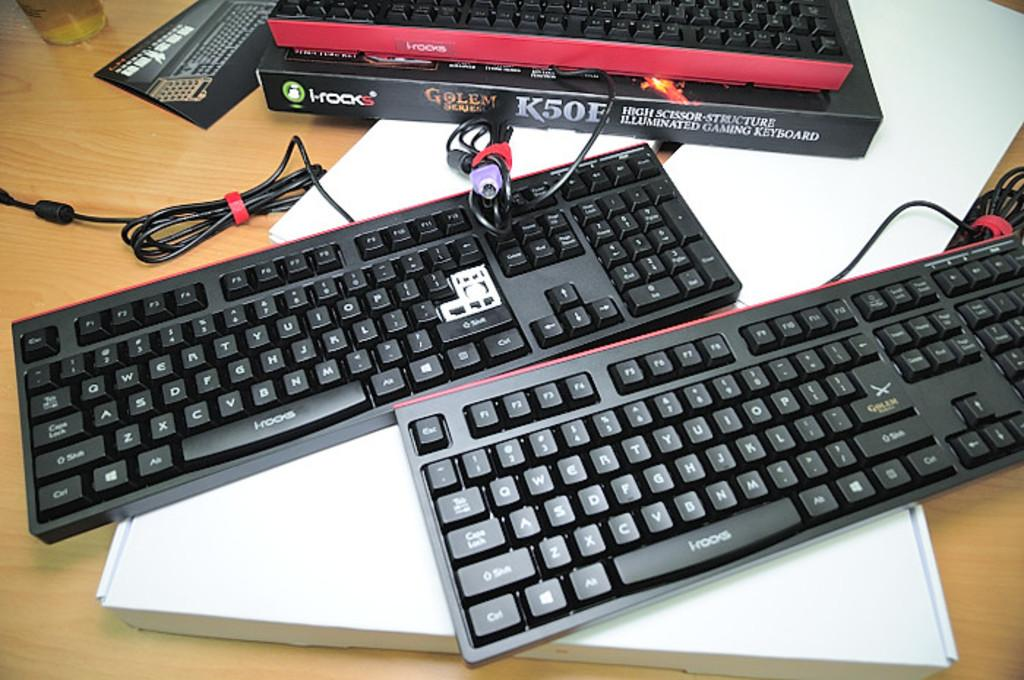<image>
Summarize the visual content of the image. two black keyboards next to boxes labeled K50 